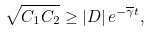<formula> <loc_0><loc_0><loc_500><loc_500>\sqrt { C _ { 1 } C _ { 2 } } \geq \left | D \right | e ^ { - \overline { \gamma } t } ,</formula> 